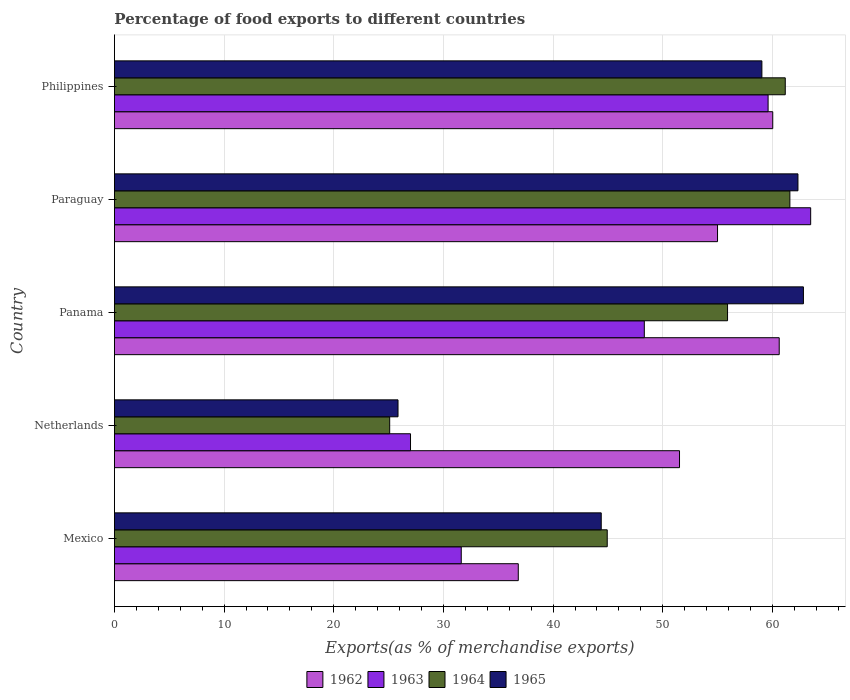What is the label of the 5th group of bars from the top?
Ensure brevity in your answer.  Mexico. What is the percentage of exports to different countries in 1965 in Mexico?
Your response must be concise. 44.39. Across all countries, what is the maximum percentage of exports to different countries in 1964?
Ensure brevity in your answer.  61.59. Across all countries, what is the minimum percentage of exports to different countries in 1964?
Your answer should be compact. 25.1. In which country was the percentage of exports to different countries in 1964 maximum?
Keep it short and to the point. Paraguay. In which country was the percentage of exports to different countries in 1965 minimum?
Offer a terse response. Netherlands. What is the total percentage of exports to different countries in 1963 in the graph?
Provide a short and direct response. 230.02. What is the difference between the percentage of exports to different countries in 1962 in Panama and that in Philippines?
Give a very brief answer. 0.59. What is the difference between the percentage of exports to different countries in 1964 in Paraguay and the percentage of exports to different countries in 1963 in Mexico?
Make the answer very short. 29.96. What is the average percentage of exports to different countries in 1963 per country?
Keep it short and to the point. 46. What is the difference between the percentage of exports to different countries in 1962 and percentage of exports to different countries in 1963 in Mexico?
Give a very brief answer. 5.2. In how many countries, is the percentage of exports to different countries in 1962 greater than 32 %?
Your answer should be very brief. 5. What is the ratio of the percentage of exports to different countries in 1962 in Paraguay to that in Philippines?
Your response must be concise. 0.92. Is the percentage of exports to different countries in 1965 in Mexico less than that in Netherlands?
Provide a succinct answer. No. What is the difference between the highest and the second highest percentage of exports to different countries in 1962?
Ensure brevity in your answer.  0.59. What is the difference between the highest and the lowest percentage of exports to different countries in 1963?
Your answer should be very brief. 36.49. In how many countries, is the percentage of exports to different countries in 1965 greater than the average percentage of exports to different countries in 1965 taken over all countries?
Give a very brief answer. 3. Is it the case that in every country, the sum of the percentage of exports to different countries in 1962 and percentage of exports to different countries in 1965 is greater than the sum of percentage of exports to different countries in 1964 and percentage of exports to different countries in 1963?
Your answer should be very brief. Yes. What does the 2nd bar from the top in Paraguay represents?
Provide a short and direct response. 1964. What does the 1st bar from the bottom in Panama represents?
Provide a short and direct response. 1962. Are the values on the major ticks of X-axis written in scientific E-notation?
Your response must be concise. No. Does the graph contain any zero values?
Provide a succinct answer. No. Does the graph contain grids?
Offer a terse response. Yes. Where does the legend appear in the graph?
Ensure brevity in your answer.  Bottom center. How many legend labels are there?
Your response must be concise. 4. What is the title of the graph?
Give a very brief answer. Percentage of food exports to different countries. What is the label or title of the X-axis?
Your response must be concise. Exports(as % of merchandise exports). What is the label or title of the Y-axis?
Give a very brief answer. Country. What is the Exports(as % of merchandise exports) in 1962 in Mexico?
Your response must be concise. 36.82. What is the Exports(as % of merchandise exports) in 1963 in Mexico?
Give a very brief answer. 31.62. What is the Exports(as % of merchandise exports) of 1964 in Mexico?
Offer a very short reply. 44.93. What is the Exports(as % of merchandise exports) in 1965 in Mexico?
Provide a succinct answer. 44.39. What is the Exports(as % of merchandise exports) of 1962 in Netherlands?
Your response must be concise. 51.52. What is the Exports(as % of merchandise exports) of 1963 in Netherlands?
Your response must be concise. 27. What is the Exports(as % of merchandise exports) of 1964 in Netherlands?
Make the answer very short. 25.1. What is the Exports(as % of merchandise exports) in 1965 in Netherlands?
Make the answer very short. 25.86. What is the Exports(as % of merchandise exports) in 1962 in Panama?
Offer a terse response. 60.62. What is the Exports(as % of merchandise exports) in 1963 in Panama?
Keep it short and to the point. 48.32. What is the Exports(as % of merchandise exports) of 1964 in Panama?
Your answer should be compact. 55.9. What is the Exports(as % of merchandise exports) of 1965 in Panama?
Give a very brief answer. 62.82. What is the Exports(as % of merchandise exports) of 1962 in Paraguay?
Make the answer very short. 54.99. What is the Exports(as % of merchandise exports) in 1963 in Paraguay?
Your response must be concise. 63.48. What is the Exports(as % of merchandise exports) in 1964 in Paraguay?
Offer a very short reply. 61.59. What is the Exports(as % of merchandise exports) in 1965 in Paraguay?
Provide a succinct answer. 62.32. What is the Exports(as % of merchandise exports) in 1962 in Philippines?
Offer a terse response. 60.03. What is the Exports(as % of merchandise exports) of 1963 in Philippines?
Offer a very short reply. 59.6. What is the Exports(as % of merchandise exports) of 1964 in Philippines?
Provide a succinct answer. 61.17. What is the Exports(as % of merchandise exports) in 1965 in Philippines?
Make the answer very short. 59.04. Across all countries, what is the maximum Exports(as % of merchandise exports) of 1962?
Your answer should be very brief. 60.62. Across all countries, what is the maximum Exports(as % of merchandise exports) in 1963?
Your answer should be very brief. 63.48. Across all countries, what is the maximum Exports(as % of merchandise exports) in 1964?
Offer a very short reply. 61.59. Across all countries, what is the maximum Exports(as % of merchandise exports) of 1965?
Ensure brevity in your answer.  62.82. Across all countries, what is the minimum Exports(as % of merchandise exports) of 1962?
Provide a short and direct response. 36.82. Across all countries, what is the minimum Exports(as % of merchandise exports) in 1963?
Offer a terse response. 27. Across all countries, what is the minimum Exports(as % of merchandise exports) in 1964?
Your answer should be compact. 25.1. Across all countries, what is the minimum Exports(as % of merchandise exports) in 1965?
Keep it short and to the point. 25.86. What is the total Exports(as % of merchandise exports) in 1962 in the graph?
Your answer should be very brief. 263.98. What is the total Exports(as % of merchandise exports) of 1963 in the graph?
Give a very brief answer. 230.02. What is the total Exports(as % of merchandise exports) in 1964 in the graph?
Offer a terse response. 248.69. What is the total Exports(as % of merchandise exports) of 1965 in the graph?
Your response must be concise. 254.43. What is the difference between the Exports(as % of merchandise exports) in 1962 in Mexico and that in Netherlands?
Provide a succinct answer. -14.7. What is the difference between the Exports(as % of merchandise exports) in 1963 in Mexico and that in Netherlands?
Give a very brief answer. 4.63. What is the difference between the Exports(as % of merchandise exports) of 1964 in Mexico and that in Netherlands?
Make the answer very short. 19.84. What is the difference between the Exports(as % of merchandise exports) in 1965 in Mexico and that in Netherlands?
Your answer should be compact. 18.53. What is the difference between the Exports(as % of merchandise exports) of 1962 in Mexico and that in Panama?
Your answer should be very brief. -23.79. What is the difference between the Exports(as % of merchandise exports) in 1963 in Mexico and that in Panama?
Make the answer very short. -16.69. What is the difference between the Exports(as % of merchandise exports) in 1964 in Mexico and that in Panama?
Ensure brevity in your answer.  -10.97. What is the difference between the Exports(as % of merchandise exports) of 1965 in Mexico and that in Panama?
Provide a succinct answer. -18.44. What is the difference between the Exports(as % of merchandise exports) of 1962 in Mexico and that in Paraguay?
Your answer should be very brief. -18.17. What is the difference between the Exports(as % of merchandise exports) in 1963 in Mexico and that in Paraguay?
Provide a succinct answer. -31.86. What is the difference between the Exports(as % of merchandise exports) of 1964 in Mexico and that in Paraguay?
Give a very brief answer. -16.65. What is the difference between the Exports(as % of merchandise exports) in 1965 in Mexico and that in Paraguay?
Your response must be concise. -17.94. What is the difference between the Exports(as % of merchandise exports) of 1962 in Mexico and that in Philippines?
Keep it short and to the point. -23.2. What is the difference between the Exports(as % of merchandise exports) in 1963 in Mexico and that in Philippines?
Provide a succinct answer. -27.98. What is the difference between the Exports(as % of merchandise exports) of 1964 in Mexico and that in Philippines?
Provide a short and direct response. -16.23. What is the difference between the Exports(as % of merchandise exports) in 1965 in Mexico and that in Philippines?
Your answer should be very brief. -14.65. What is the difference between the Exports(as % of merchandise exports) of 1962 in Netherlands and that in Panama?
Your answer should be very brief. -9.09. What is the difference between the Exports(as % of merchandise exports) in 1963 in Netherlands and that in Panama?
Make the answer very short. -21.32. What is the difference between the Exports(as % of merchandise exports) in 1964 in Netherlands and that in Panama?
Ensure brevity in your answer.  -30.81. What is the difference between the Exports(as % of merchandise exports) in 1965 in Netherlands and that in Panama?
Keep it short and to the point. -36.96. What is the difference between the Exports(as % of merchandise exports) in 1962 in Netherlands and that in Paraguay?
Your answer should be very brief. -3.47. What is the difference between the Exports(as % of merchandise exports) in 1963 in Netherlands and that in Paraguay?
Provide a succinct answer. -36.49. What is the difference between the Exports(as % of merchandise exports) in 1964 in Netherlands and that in Paraguay?
Provide a short and direct response. -36.49. What is the difference between the Exports(as % of merchandise exports) in 1965 in Netherlands and that in Paraguay?
Provide a short and direct response. -36.47. What is the difference between the Exports(as % of merchandise exports) of 1962 in Netherlands and that in Philippines?
Ensure brevity in your answer.  -8.5. What is the difference between the Exports(as % of merchandise exports) in 1963 in Netherlands and that in Philippines?
Your answer should be compact. -32.6. What is the difference between the Exports(as % of merchandise exports) in 1964 in Netherlands and that in Philippines?
Your answer should be compact. -36.07. What is the difference between the Exports(as % of merchandise exports) in 1965 in Netherlands and that in Philippines?
Your answer should be very brief. -33.18. What is the difference between the Exports(as % of merchandise exports) in 1962 in Panama and that in Paraguay?
Keep it short and to the point. 5.62. What is the difference between the Exports(as % of merchandise exports) of 1963 in Panama and that in Paraguay?
Keep it short and to the point. -15.17. What is the difference between the Exports(as % of merchandise exports) in 1964 in Panama and that in Paraguay?
Make the answer very short. -5.68. What is the difference between the Exports(as % of merchandise exports) in 1965 in Panama and that in Paraguay?
Your response must be concise. 0.5. What is the difference between the Exports(as % of merchandise exports) in 1962 in Panama and that in Philippines?
Your response must be concise. 0.59. What is the difference between the Exports(as % of merchandise exports) of 1963 in Panama and that in Philippines?
Your answer should be very brief. -11.29. What is the difference between the Exports(as % of merchandise exports) of 1964 in Panama and that in Philippines?
Provide a short and direct response. -5.26. What is the difference between the Exports(as % of merchandise exports) in 1965 in Panama and that in Philippines?
Offer a very short reply. 3.79. What is the difference between the Exports(as % of merchandise exports) of 1962 in Paraguay and that in Philippines?
Provide a short and direct response. -5.03. What is the difference between the Exports(as % of merchandise exports) in 1963 in Paraguay and that in Philippines?
Provide a short and direct response. 3.88. What is the difference between the Exports(as % of merchandise exports) in 1964 in Paraguay and that in Philippines?
Provide a succinct answer. 0.42. What is the difference between the Exports(as % of merchandise exports) of 1965 in Paraguay and that in Philippines?
Keep it short and to the point. 3.29. What is the difference between the Exports(as % of merchandise exports) in 1962 in Mexico and the Exports(as % of merchandise exports) in 1963 in Netherlands?
Offer a terse response. 9.83. What is the difference between the Exports(as % of merchandise exports) in 1962 in Mexico and the Exports(as % of merchandise exports) in 1964 in Netherlands?
Your answer should be compact. 11.72. What is the difference between the Exports(as % of merchandise exports) of 1962 in Mexico and the Exports(as % of merchandise exports) of 1965 in Netherlands?
Provide a short and direct response. 10.96. What is the difference between the Exports(as % of merchandise exports) of 1963 in Mexico and the Exports(as % of merchandise exports) of 1964 in Netherlands?
Provide a short and direct response. 6.53. What is the difference between the Exports(as % of merchandise exports) in 1963 in Mexico and the Exports(as % of merchandise exports) in 1965 in Netherlands?
Ensure brevity in your answer.  5.77. What is the difference between the Exports(as % of merchandise exports) of 1964 in Mexico and the Exports(as % of merchandise exports) of 1965 in Netherlands?
Give a very brief answer. 19.08. What is the difference between the Exports(as % of merchandise exports) in 1962 in Mexico and the Exports(as % of merchandise exports) in 1963 in Panama?
Make the answer very short. -11.49. What is the difference between the Exports(as % of merchandise exports) of 1962 in Mexico and the Exports(as % of merchandise exports) of 1964 in Panama?
Make the answer very short. -19.08. What is the difference between the Exports(as % of merchandise exports) of 1962 in Mexico and the Exports(as % of merchandise exports) of 1965 in Panama?
Provide a succinct answer. -26. What is the difference between the Exports(as % of merchandise exports) of 1963 in Mexico and the Exports(as % of merchandise exports) of 1964 in Panama?
Provide a succinct answer. -24.28. What is the difference between the Exports(as % of merchandise exports) of 1963 in Mexico and the Exports(as % of merchandise exports) of 1965 in Panama?
Keep it short and to the point. -31.2. What is the difference between the Exports(as % of merchandise exports) of 1964 in Mexico and the Exports(as % of merchandise exports) of 1965 in Panama?
Your answer should be very brief. -17.89. What is the difference between the Exports(as % of merchandise exports) in 1962 in Mexico and the Exports(as % of merchandise exports) in 1963 in Paraguay?
Your answer should be compact. -26.66. What is the difference between the Exports(as % of merchandise exports) in 1962 in Mexico and the Exports(as % of merchandise exports) in 1964 in Paraguay?
Your response must be concise. -24.76. What is the difference between the Exports(as % of merchandise exports) of 1962 in Mexico and the Exports(as % of merchandise exports) of 1965 in Paraguay?
Provide a short and direct response. -25.5. What is the difference between the Exports(as % of merchandise exports) in 1963 in Mexico and the Exports(as % of merchandise exports) in 1964 in Paraguay?
Provide a succinct answer. -29.96. What is the difference between the Exports(as % of merchandise exports) in 1963 in Mexico and the Exports(as % of merchandise exports) in 1965 in Paraguay?
Give a very brief answer. -30.7. What is the difference between the Exports(as % of merchandise exports) of 1964 in Mexico and the Exports(as % of merchandise exports) of 1965 in Paraguay?
Your answer should be very brief. -17.39. What is the difference between the Exports(as % of merchandise exports) of 1962 in Mexico and the Exports(as % of merchandise exports) of 1963 in Philippines?
Make the answer very short. -22.78. What is the difference between the Exports(as % of merchandise exports) in 1962 in Mexico and the Exports(as % of merchandise exports) in 1964 in Philippines?
Offer a very short reply. -24.34. What is the difference between the Exports(as % of merchandise exports) of 1962 in Mexico and the Exports(as % of merchandise exports) of 1965 in Philippines?
Give a very brief answer. -22.21. What is the difference between the Exports(as % of merchandise exports) in 1963 in Mexico and the Exports(as % of merchandise exports) in 1964 in Philippines?
Offer a terse response. -29.54. What is the difference between the Exports(as % of merchandise exports) of 1963 in Mexico and the Exports(as % of merchandise exports) of 1965 in Philippines?
Provide a short and direct response. -27.41. What is the difference between the Exports(as % of merchandise exports) of 1964 in Mexico and the Exports(as % of merchandise exports) of 1965 in Philippines?
Your answer should be very brief. -14.1. What is the difference between the Exports(as % of merchandise exports) in 1962 in Netherlands and the Exports(as % of merchandise exports) in 1963 in Panama?
Make the answer very short. 3.21. What is the difference between the Exports(as % of merchandise exports) in 1962 in Netherlands and the Exports(as % of merchandise exports) in 1964 in Panama?
Your answer should be very brief. -4.38. What is the difference between the Exports(as % of merchandise exports) of 1962 in Netherlands and the Exports(as % of merchandise exports) of 1965 in Panama?
Provide a short and direct response. -11.3. What is the difference between the Exports(as % of merchandise exports) of 1963 in Netherlands and the Exports(as % of merchandise exports) of 1964 in Panama?
Your answer should be compact. -28.91. What is the difference between the Exports(as % of merchandise exports) in 1963 in Netherlands and the Exports(as % of merchandise exports) in 1965 in Panama?
Your response must be concise. -35.82. What is the difference between the Exports(as % of merchandise exports) of 1964 in Netherlands and the Exports(as % of merchandise exports) of 1965 in Panama?
Provide a short and direct response. -37.72. What is the difference between the Exports(as % of merchandise exports) in 1962 in Netherlands and the Exports(as % of merchandise exports) in 1963 in Paraguay?
Offer a terse response. -11.96. What is the difference between the Exports(as % of merchandise exports) of 1962 in Netherlands and the Exports(as % of merchandise exports) of 1964 in Paraguay?
Provide a succinct answer. -10.06. What is the difference between the Exports(as % of merchandise exports) of 1962 in Netherlands and the Exports(as % of merchandise exports) of 1965 in Paraguay?
Your response must be concise. -10.8. What is the difference between the Exports(as % of merchandise exports) of 1963 in Netherlands and the Exports(as % of merchandise exports) of 1964 in Paraguay?
Provide a succinct answer. -34.59. What is the difference between the Exports(as % of merchandise exports) in 1963 in Netherlands and the Exports(as % of merchandise exports) in 1965 in Paraguay?
Your response must be concise. -35.33. What is the difference between the Exports(as % of merchandise exports) in 1964 in Netherlands and the Exports(as % of merchandise exports) in 1965 in Paraguay?
Ensure brevity in your answer.  -37.23. What is the difference between the Exports(as % of merchandise exports) in 1962 in Netherlands and the Exports(as % of merchandise exports) in 1963 in Philippines?
Offer a very short reply. -8.08. What is the difference between the Exports(as % of merchandise exports) in 1962 in Netherlands and the Exports(as % of merchandise exports) in 1964 in Philippines?
Your answer should be very brief. -9.64. What is the difference between the Exports(as % of merchandise exports) in 1962 in Netherlands and the Exports(as % of merchandise exports) in 1965 in Philippines?
Give a very brief answer. -7.51. What is the difference between the Exports(as % of merchandise exports) of 1963 in Netherlands and the Exports(as % of merchandise exports) of 1964 in Philippines?
Keep it short and to the point. -34.17. What is the difference between the Exports(as % of merchandise exports) in 1963 in Netherlands and the Exports(as % of merchandise exports) in 1965 in Philippines?
Provide a succinct answer. -32.04. What is the difference between the Exports(as % of merchandise exports) in 1964 in Netherlands and the Exports(as % of merchandise exports) in 1965 in Philippines?
Make the answer very short. -33.94. What is the difference between the Exports(as % of merchandise exports) of 1962 in Panama and the Exports(as % of merchandise exports) of 1963 in Paraguay?
Make the answer very short. -2.87. What is the difference between the Exports(as % of merchandise exports) in 1962 in Panama and the Exports(as % of merchandise exports) in 1964 in Paraguay?
Give a very brief answer. -0.97. What is the difference between the Exports(as % of merchandise exports) in 1962 in Panama and the Exports(as % of merchandise exports) in 1965 in Paraguay?
Offer a very short reply. -1.71. What is the difference between the Exports(as % of merchandise exports) of 1963 in Panama and the Exports(as % of merchandise exports) of 1964 in Paraguay?
Your answer should be very brief. -13.27. What is the difference between the Exports(as % of merchandise exports) in 1963 in Panama and the Exports(as % of merchandise exports) in 1965 in Paraguay?
Make the answer very short. -14.01. What is the difference between the Exports(as % of merchandise exports) of 1964 in Panama and the Exports(as % of merchandise exports) of 1965 in Paraguay?
Give a very brief answer. -6.42. What is the difference between the Exports(as % of merchandise exports) of 1962 in Panama and the Exports(as % of merchandise exports) of 1963 in Philippines?
Keep it short and to the point. 1.01. What is the difference between the Exports(as % of merchandise exports) in 1962 in Panama and the Exports(as % of merchandise exports) in 1964 in Philippines?
Ensure brevity in your answer.  -0.55. What is the difference between the Exports(as % of merchandise exports) of 1962 in Panama and the Exports(as % of merchandise exports) of 1965 in Philippines?
Ensure brevity in your answer.  1.58. What is the difference between the Exports(as % of merchandise exports) of 1963 in Panama and the Exports(as % of merchandise exports) of 1964 in Philippines?
Ensure brevity in your answer.  -12.85. What is the difference between the Exports(as % of merchandise exports) of 1963 in Panama and the Exports(as % of merchandise exports) of 1965 in Philippines?
Your answer should be very brief. -10.72. What is the difference between the Exports(as % of merchandise exports) in 1964 in Panama and the Exports(as % of merchandise exports) in 1965 in Philippines?
Ensure brevity in your answer.  -3.13. What is the difference between the Exports(as % of merchandise exports) of 1962 in Paraguay and the Exports(as % of merchandise exports) of 1963 in Philippines?
Keep it short and to the point. -4.61. What is the difference between the Exports(as % of merchandise exports) of 1962 in Paraguay and the Exports(as % of merchandise exports) of 1964 in Philippines?
Provide a short and direct response. -6.18. What is the difference between the Exports(as % of merchandise exports) in 1962 in Paraguay and the Exports(as % of merchandise exports) in 1965 in Philippines?
Keep it short and to the point. -4.04. What is the difference between the Exports(as % of merchandise exports) of 1963 in Paraguay and the Exports(as % of merchandise exports) of 1964 in Philippines?
Keep it short and to the point. 2.32. What is the difference between the Exports(as % of merchandise exports) in 1963 in Paraguay and the Exports(as % of merchandise exports) in 1965 in Philippines?
Keep it short and to the point. 4.45. What is the difference between the Exports(as % of merchandise exports) of 1964 in Paraguay and the Exports(as % of merchandise exports) of 1965 in Philippines?
Give a very brief answer. 2.55. What is the average Exports(as % of merchandise exports) in 1962 per country?
Give a very brief answer. 52.8. What is the average Exports(as % of merchandise exports) in 1963 per country?
Your answer should be very brief. 46. What is the average Exports(as % of merchandise exports) of 1964 per country?
Provide a short and direct response. 49.74. What is the average Exports(as % of merchandise exports) in 1965 per country?
Make the answer very short. 50.89. What is the difference between the Exports(as % of merchandise exports) of 1962 and Exports(as % of merchandise exports) of 1963 in Mexico?
Offer a very short reply. 5.2. What is the difference between the Exports(as % of merchandise exports) of 1962 and Exports(as % of merchandise exports) of 1964 in Mexico?
Keep it short and to the point. -8.11. What is the difference between the Exports(as % of merchandise exports) in 1962 and Exports(as % of merchandise exports) in 1965 in Mexico?
Provide a succinct answer. -7.56. What is the difference between the Exports(as % of merchandise exports) of 1963 and Exports(as % of merchandise exports) of 1964 in Mexico?
Your answer should be compact. -13.31. What is the difference between the Exports(as % of merchandise exports) in 1963 and Exports(as % of merchandise exports) in 1965 in Mexico?
Provide a short and direct response. -12.76. What is the difference between the Exports(as % of merchandise exports) in 1964 and Exports(as % of merchandise exports) in 1965 in Mexico?
Provide a succinct answer. 0.55. What is the difference between the Exports(as % of merchandise exports) of 1962 and Exports(as % of merchandise exports) of 1963 in Netherlands?
Provide a succinct answer. 24.53. What is the difference between the Exports(as % of merchandise exports) in 1962 and Exports(as % of merchandise exports) in 1964 in Netherlands?
Make the answer very short. 26.43. What is the difference between the Exports(as % of merchandise exports) in 1962 and Exports(as % of merchandise exports) in 1965 in Netherlands?
Provide a short and direct response. 25.67. What is the difference between the Exports(as % of merchandise exports) of 1963 and Exports(as % of merchandise exports) of 1964 in Netherlands?
Give a very brief answer. 1.9. What is the difference between the Exports(as % of merchandise exports) in 1963 and Exports(as % of merchandise exports) in 1965 in Netherlands?
Ensure brevity in your answer.  1.14. What is the difference between the Exports(as % of merchandise exports) of 1964 and Exports(as % of merchandise exports) of 1965 in Netherlands?
Provide a succinct answer. -0.76. What is the difference between the Exports(as % of merchandise exports) in 1962 and Exports(as % of merchandise exports) in 1963 in Panama?
Offer a terse response. 12.3. What is the difference between the Exports(as % of merchandise exports) in 1962 and Exports(as % of merchandise exports) in 1964 in Panama?
Make the answer very short. 4.71. What is the difference between the Exports(as % of merchandise exports) of 1962 and Exports(as % of merchandise exports) of 1965 in Panama?
Ensure brevity in your answer.  -2.21. What is the difference between the Exports(as % of merchandise exports) in 1963 and Exports(as % of merchandise exports) in 1964 in Panama?
Keep it short and to the point. -7.59. What is the difference between the Exports(as % of merchandise exports) in 1963 and Exports(as % of merchandise exports) in 1965 in Panama?
Give a very brief answer. -14.51. What is the difference between the Exports(as % of merchandise exports) of 1964 and Exports(as % of merchandise exports) of 1965 in Panama?
Offer a very short reply. -6.92. What is the difference between the Exports(as % of merchandise exports) of 1962 and Exports(as % of merchandise exports) of 1963 in Paraguay?
Give a very brief answer. -8.49. What is the difference between the Exports(as % of merchandise exports) in 1962 and Exports(as % of merchandise exports) in 1964 in Paraguay?
Make the answer very short. -6.6. What is the difference between the Exports(as % of merchandise exports) of 1962 and Exports(as % of merchandise exports) of 1965 in Paraguay?
Your answer should be very brief. -7.33. What is the difference between the Exports(as % of merchandise exports) in 1963 and Exports(as % of merchandise exports) in 1964 in Paraguay?
Offer a very short reply. 1.9. What is the difference between the Exports(as % of merchandise exports) in 1963 and Exports(as % of merchandise exports) in 1965 in Paraguay?
Provide a short and direct response. 1.16. What is the difference between the Exports(as % of merchandise exports) of 1964 and Exports(as % of merchandise exports) of 1965 in Paraguay?
Your answer should be very brief. -0.74. What is the difference between the Exports(as % of merchandise exports) of 1962 and Exports(as % of merchandise exports) of 1963 in Philippines?
Your answer should be compact. 0.42. What is the difference between the Exports(as % of merchandise exports) in 1962 and Exports(as % of merchandise exports) in 1964 in Philippines?
Give a very brief answer. -1.14. What is the difference between the Exports(as % of merchandise exports) of 1963 and Exports(as % of merchandise exports) of 1964 in Philippines?
Offer a very short reply. -1.57. What is the difference between the Exports(as % of merchandise exports) of 1963 and Exports(as % of merchandise exports) of 1965 in Philippines?
Your answer should be very brief. 0.57. What is the difference between the Exports(as % of merchandise exports) of 1964 and Exports(as % of merchandise exports) of 1965 in Philippines?
Offer a terse response. 2.13. What is the ratio of the Exports(as % of merchandise exports) of 1962 in Mexico to that in Netherlands?
Provide a succinct answer. 0.71. What is the ratio of the Exports(as % of merchandise exports) of 1963 in Mexico to that in Netherlands?
Your response must be concise. 1.17. What is the ratio of the Exports(as % of merchandise exports) of 1964 in Mexico to that in Netherlands?
Offer a terse response. 1.79. What is the ratio of the Exports(as % of merchandise exports) in 1965 in Mexico to that in Netherlands?
Your answer should be very brief. 1.72. What is the ratio of the Exports(as % of merchandise exports) in 1962 in Mexico to that in Panama?
Provide a succinct answer. 0.61. What is the ratio of the Exports(as % of merchandise exports) of 1963 in Mexico to that in Panama?
Your answer should be compact. 0.65. What is the ratio of the Exports(as % of merchandise exports) in 1964 in Mexico to that in Panama?
Provide a succinct answer. 0.8. What is the ratio of the Exports(as % of merchandise exports) of 1965 in Mexico to that in Panama?
Provide a succinct answer. 0.71. What is the ratio of the Exports(as % of merchandise exports) of 1962 in Mexico to that in Paraguay?
Offer a terse response. 0.67. What is the ratio of the Exports(as % of merchandise exports) in 1963 in Mexico to that in Paraguay?
Offer a very short reply. 0.5. What is the ratio of the Exports(as % of merchandise exports) in 1964 in Mexico to that in Paraguay?
Your response must be concise. 0.73. What is the ratio of the Exports(as % of merchandise exports) in 1965 in Mexico to that in Paraguay?
Offer a terse response. 0.71. What is the ratio of the Exports(as % of merchandise exports) of 1962 in Mexico to that in Philippines?
Your response must be concise. 0.61. What is the ratio of the Exports(as % of merchandise exports) of 1963 in Mexico to that in Philippines?
Provide a short and direct response. 0.53. What is the ratio of the Exports(as % of merchandise exports) of 1964 in Mexico to that in Philippines?
Provide a succinct answer. 0.73. What is the ratio of the Exports(as % of merchandise exports) in 1965 in Mexico to that in Philippines?
Offer a terse response. 0.75. What is the ratio of the Exports(as % of merchandise exports) in 1962 in Netherlands to that in Panama?
Your answer should be very brief. 0.85. What is the ratio of the Exports(as % of merchandise exports) in 1963 in Netherlands to that in Panama?
Offer a terse response. 0.56. What is the ratio of the Exports(as % of merchandise exports) of 1964 in Netherlands to that in Panama?
Your response must be concise. 0.45. What is the ratio of the Exports(as % of merchandise exports) in 1965 in Netherlands to that in Panama?
Your response must be concise. 0.41. What is the ratio of the Exports(as % of merchandise exports) in 1962 in Netherlands to that in Paraguay?
Offer a very short reply. 0.94. What is the ratio of the Exports(as % of merchandise exports) of 1963 in Netherlands to that in Paraguay?
Make the answer very short. 0.43. What is the ratio of the Exports(as % of merchandise exports) of 1964 in Netherlands to that in Paraguay?
Keep it short and to the point. 0.41. What is the ratio of the Exports(as % of merchandise exports) in 1965 in Netherlands to that in Paraguay?
Give a very brief answer. 0.41. What is the ratio of the Exports(as % of merchandise exports) of 1962 in Netherlands to that in Philippines?
Your answer should be compact. 0.86. What is the ratio of the Exports(as % of merchandise exports) of 1963 in Netherlands to that in Philippines?
Provide a short and direct response. 0.45. What is the ratio of the Exports(as % of merchandise exports) of 1964 in Netherlands to that in Philippines?
Your response must be concise. 0.41. What is the ratio of the Exports(as % of merchandise exports) in 1965 in Netherlands to that in Philippines?
Keep it short and to the point. 0.44. What is the ratio of the Exports(as % of merchandise exports) of 1962 in Panama to that in Paraguay?
Make the answer very short. 1.1. What is the ratio of the Exports(as % of merchandise exports) in 1963 in Panama to that in Paraguay?
Offer a very short reply. 0.76. What is the ratio of the Exports(as % of merchandise exports) in 1964 in Panama to that in Paraguay?
Make the answer very short. 0.91. What is the ratio of the Exports(as % of merchandise exports) of 1965 in Panama to that in Paraguay?
Your answer should be compact. 1.01. What is the ratio of the Exports(as % of merchandise exports) of 1962 in Panama to that in Philippines?
Give a very brief answer. 1.01. What is the ratio of the Exports(as % of merchandise exports) in 1963 in Panama to that in Philippines?
Offer a very short reply. 0.81. What is the ratio of the Exports(as % of merchandise exports) of 1964 in Panama to that in Philippines?
Offer a very short reply. 0.91. What is the ratio of the Exports(as % of merchandise exports) of 1965 in Panama to that in Philippines?
Your answer should be very brief. 1.06. What is the ratio of the Exports(as % of merchandise exports) of 1962 in Paraguay to that in Philippines?
Keep it short and to the point. 0.92. What is the ratio of the Exports(as % of merchandise exports) in 1963 in Paraguay to that in Philippines?
Give a very brief answer. 1.07. What is the ratio of the Exports(as % of merchandise exports) of 1965 in Paraguay to that in Philippines?
Your answer should be very brief. 1.06. What is the difference between the highest and the second highest Exports(as % of merchandise exports) of 1962?
Offer a very short reply. 0.59. What is the difference between the highest and the second highest Exports(as % of merchandise exports) of 1963?
Make the answer very short. 3.88. What is the difference between the highest and the second highest Exports(as % of merchandise exports) of 1964?
Offer a terse response. 0.42. What is the difference between the highest and the second highest Exports(as % of merchandise exports) of 1965?
Provide a succinct answer. 0.5. What is the difference between the highest and the lowest Exports(as % of merchandise exports) of 1962?
Keep it short and to the point. 23.79. What is the difference between the highest and the lowest Exports(as % of merchandise exports) in 1963?
Your answer should be compact. 36.49. What is the difference between the highest and the lowest Exports(as % of merchandise exports) in 1964?
Provide a succinct answer. 36.49. What is the difference between the highest and the lowest Exports(as % of merchandise exports) of 1965?
Your answer should be compact. 36.96. 